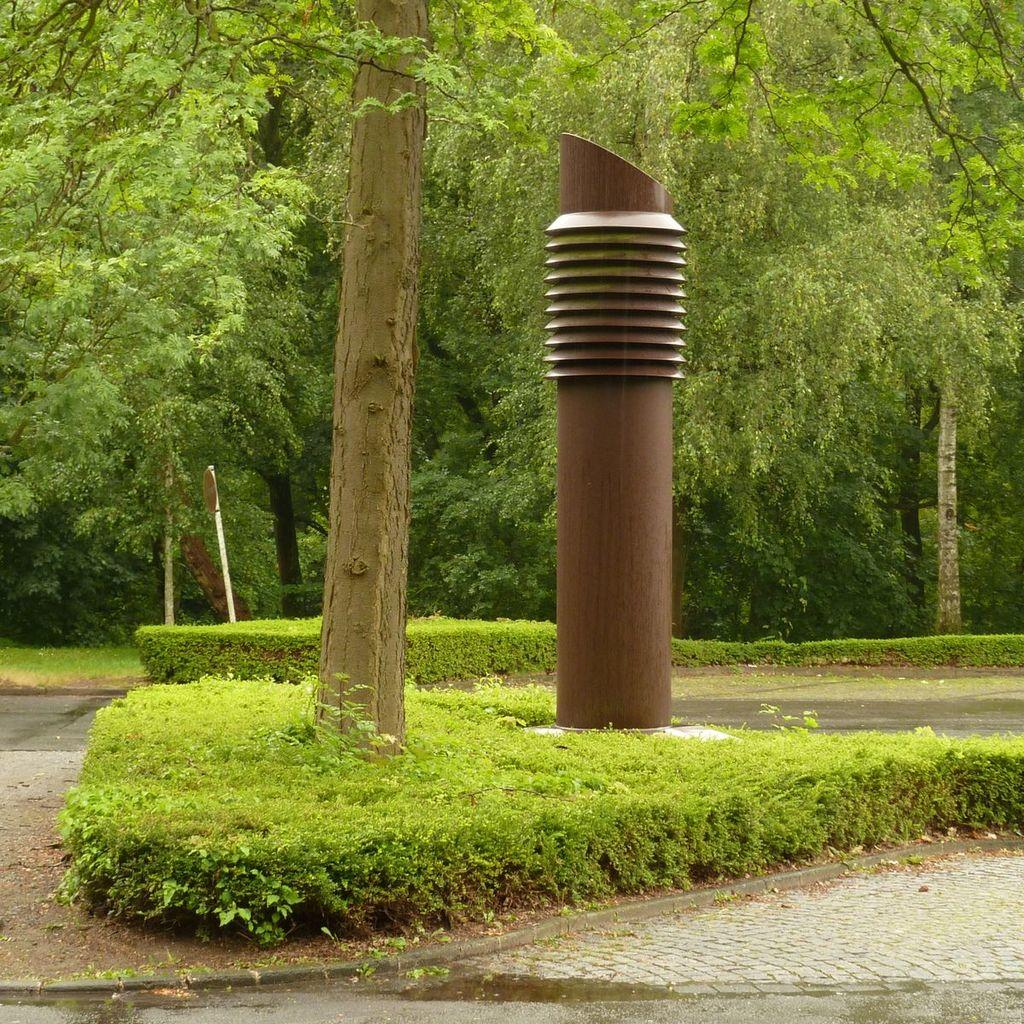What type of structure is present in the image? There is a concrete pole structure in the image. Where is the pole structure located in relation to the plants and trees? The pole structure is placed near plants and trees. What can be seen in the background of the image? There are many plants, trees, and grass in the background of the image. What season is depicted in the image? The provided facts do not mention any specific season, so it cannot be determined from the image. 